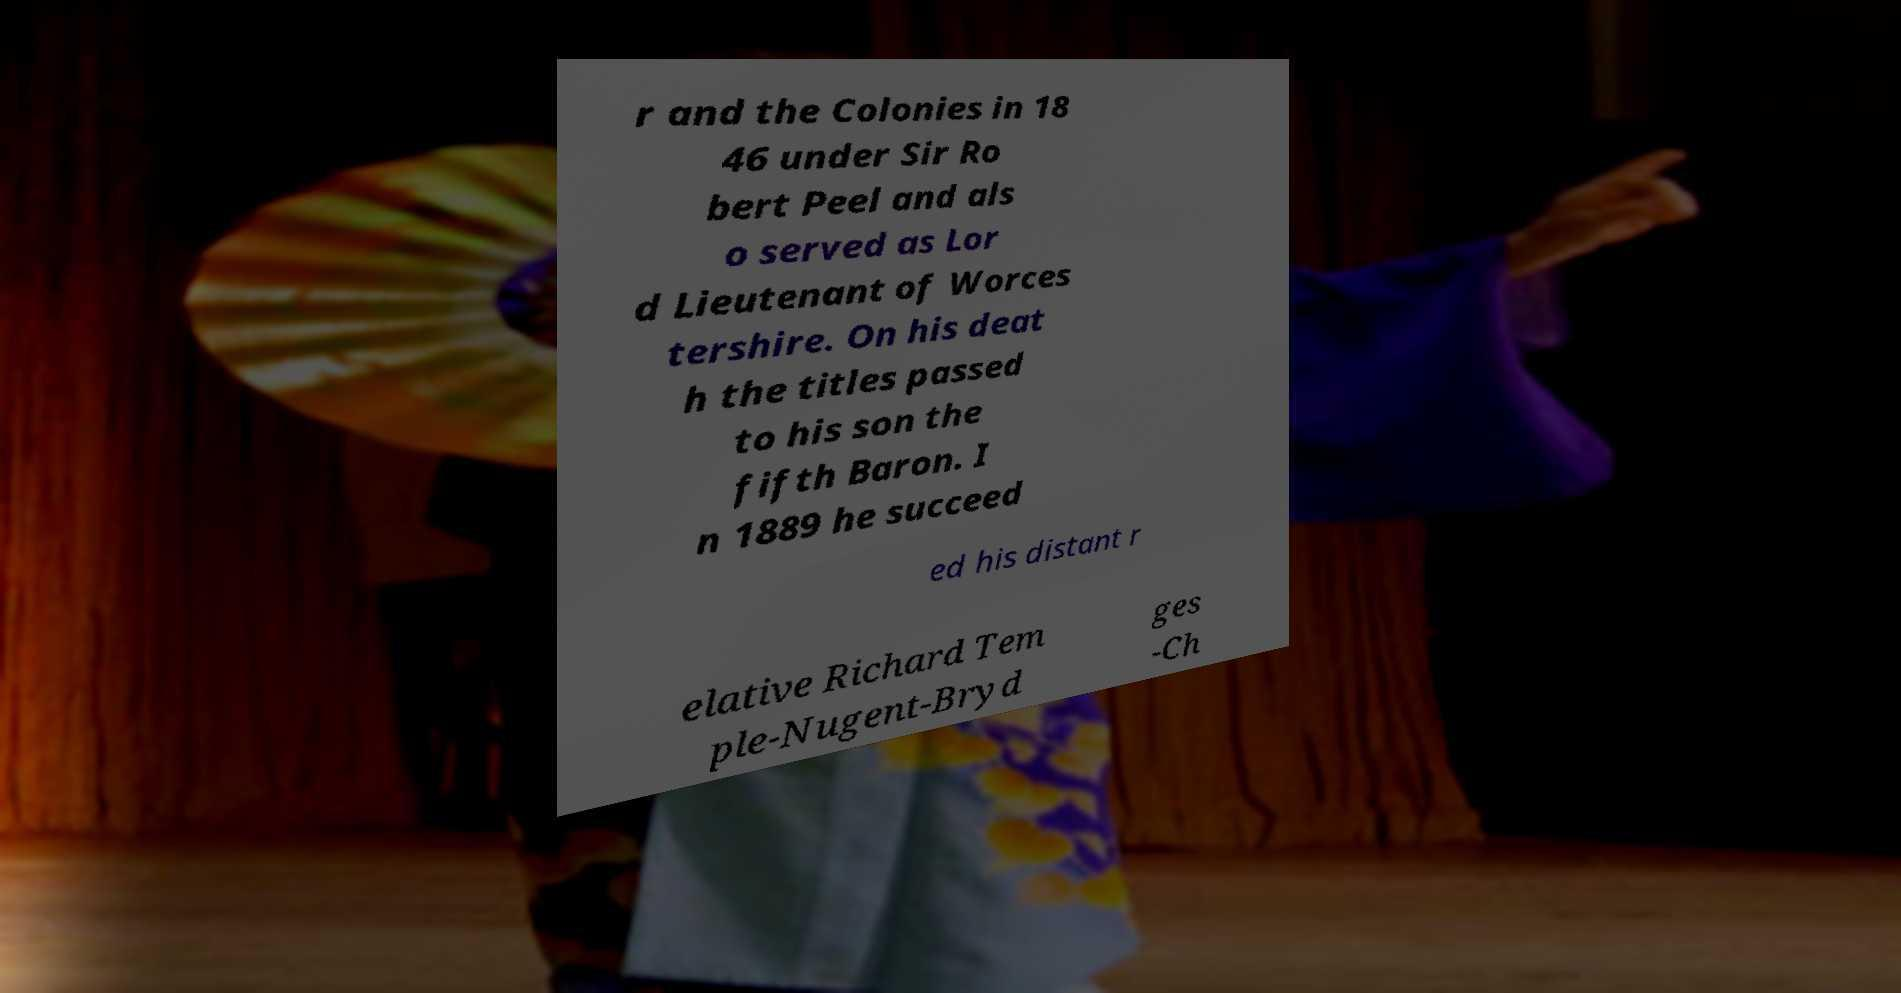Could you assist in decoding the text presented in this image and type it out clearly? r and the Colonies in 18 46 under Sir Ro bert Peel and als o served as Lor d Lieutenant of Worces tershire. On his deat h the titles passed to his son the fifth Baron. I n 1889 he succeed ed his distant r elative Richard Tem ple-Nugent-Bryd ges -Ch 